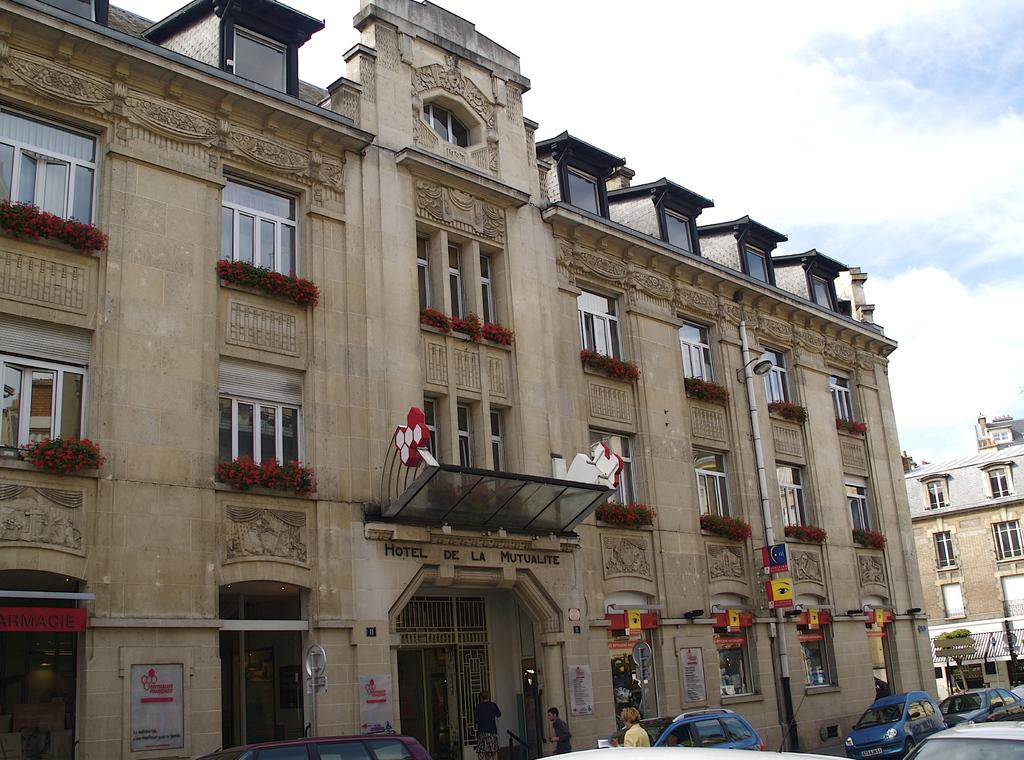What type of structures can be seen in the image? There are buildings in the image. What other elements can be found in the image besides buildings? There are plants, flowers, windows, people, vehicles, and the sky visible in the image. Can you describe the sky in the image? The sky is visible in the image, and clouds are present. What might be used for transportation in the image? There are vehicles in the image that can be used for transportation. What is the weight of the chain hanging from the building in the image? There is no chain hanging from any building in the image. Can you tell me how many people are driving vehicles in the image? There is no information about people driving vehicles in the image; we only know that there are vehicles present. 